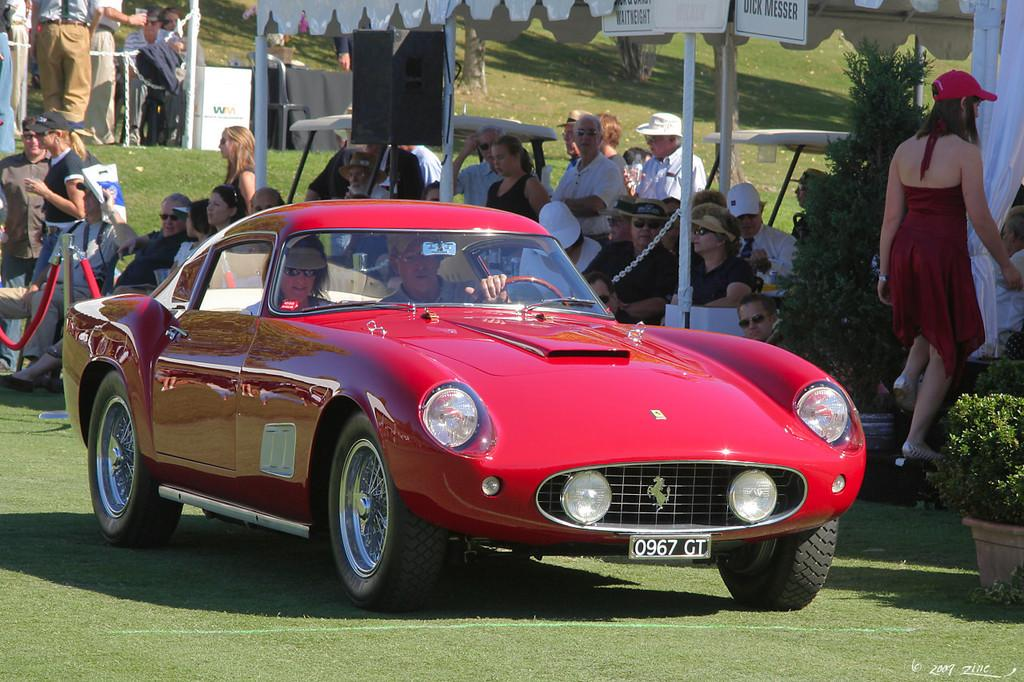What color is the car in the image? The car in the image is red. Where is the car located in the image? The car is on the ground. Can you describe the people behind the car? There is a group of people behind the car. What type of jeans is the uncle wearing in the image? There is no uncle or jeans present in the image. 